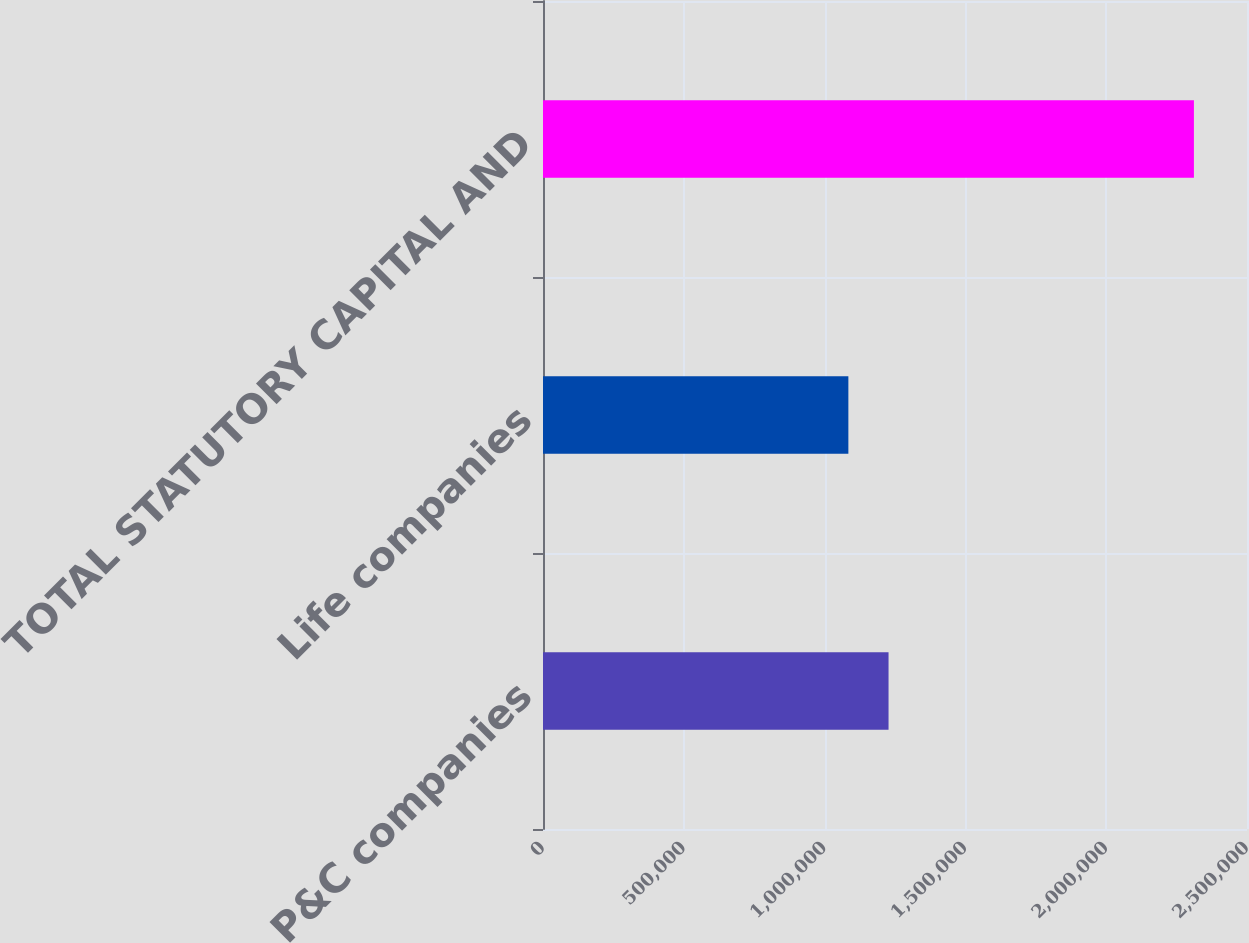Convert chart to OTSL. <chart><loc_0><loc_0><loc_500><loc_500><bar_chart><fcel>P&C companies<fcel>Life companies<fcel>TOTAL STATUTORY CAPITAL AND<nl><fcel>1.22708e+06<fcel>1.08441e+06<fcel>2.31149e+06<nl></chart> 